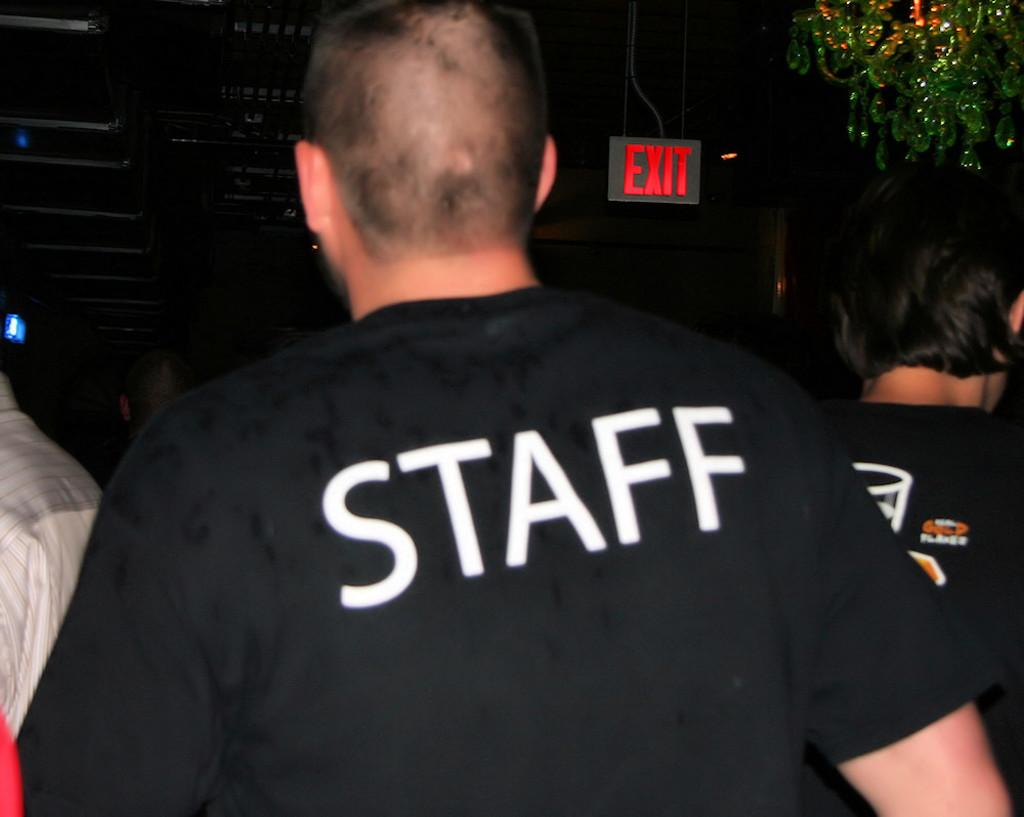Who or what can be seen in the image? There are people in the image. Can you describe any specific details about the people's clothing? There is text visible on a T-shirt. What else is present in the image besides the people? There is an exit board in the image. What is the taste of the feet in the image? There are no feet mentioned or visible in the image, so it is not possible to determine their taste. 